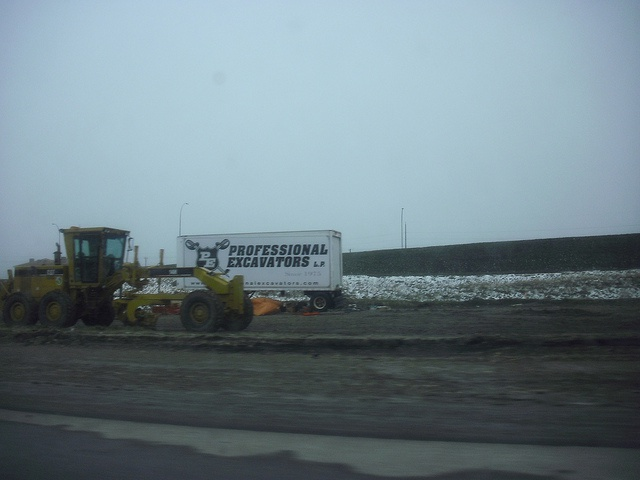Describe the objects in this image and their specific colors. I can see truck in darkgray, black, gray, and darkgreen tones and truck in darkgray, gray, and black tones in this image. 